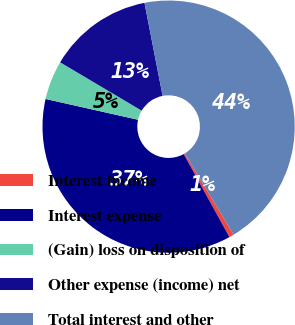Convert chart to OTSL. <chart><loc_0><loc_0><loc_500><loc_500><pie_chart><fcel>Interest income<fcel>Interest expense<fcel>(Gain) loss on disposition of<fcel>Other expense (income) net<fcel>Total interest and other<nl><fcel>0.62%<fcel>36.53%<fcel>5.0%<fcel>13.42%<fcel>44.44%<nl></chart> 